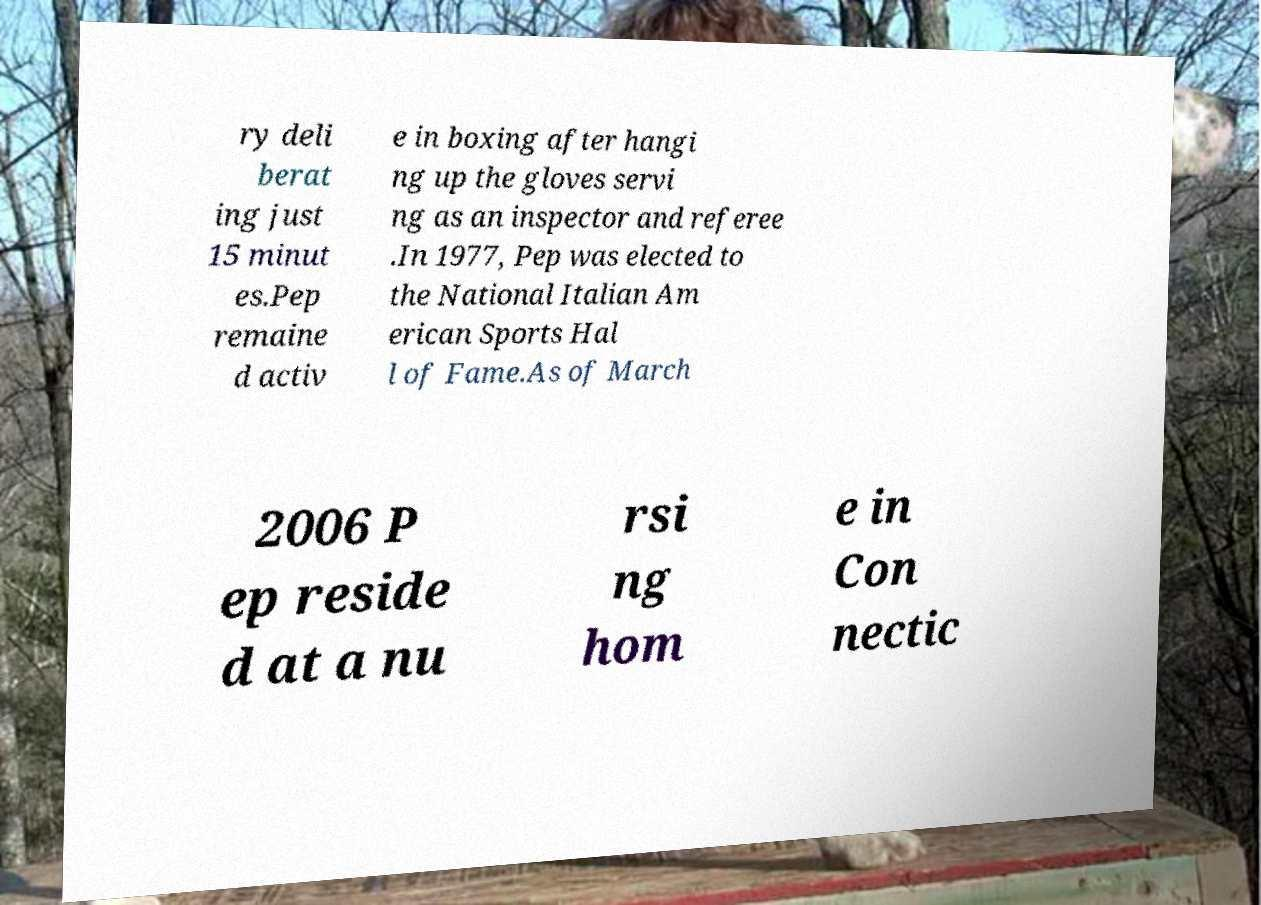Can you accurately transcribe the text from the provided image for me? ry deli berat ing just 15 minut es.Pep remaine d activ e in boxing after hangi ng up the gloves servi ng as an inspector and referee .In 1977, Pep was elected to the National Italian Am erican Sports Hal l of Fame.As of March 2006 P ep reside d at a nu rsi ng hom e in Con nectic 